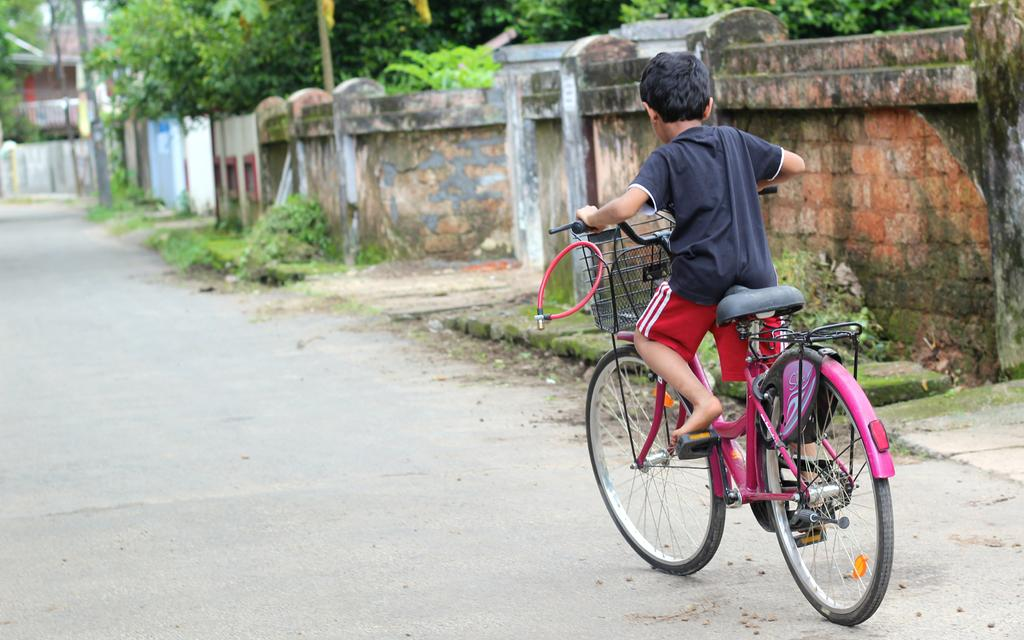What is the person in the image doing? The person is riding a bicycle in the image. What color is the bicycle? The bicycle is pink in color. Where is the person riding the bicycle? The person is riding the bicycle on the road. What can be seen on the right side of the image? There is a brick wall on the right side of the image. What is located behind the brick wall? There are trees behind the brick wall. What type of sea creature can be seen swimming near the person riding the bicycle? There is no sea creature present in the image, as it is set on a road with a brick wall and trees. 